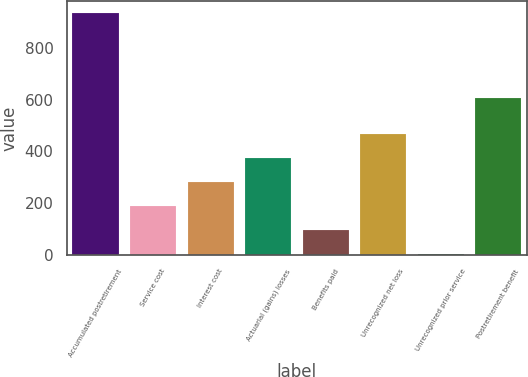<chart> <loc_0><loc_0><loc_500><loc_500><bar_chart><fcel>Accumulated postretirement<fcel>Service cost<fcel>Interest cost<fcel>Actuarial (gains) losses<fcel>Benefits paid<fcel>Unrecognized net loss<fcel>Unrecognized prior service<fcel>Postretirement benefit<nl><fcel>933<fcel>188.2<fcel>281.3<fcel>374.4<fcel>95.1<fcel>467.5<fcel>2<fcel>605<nl></chart> 